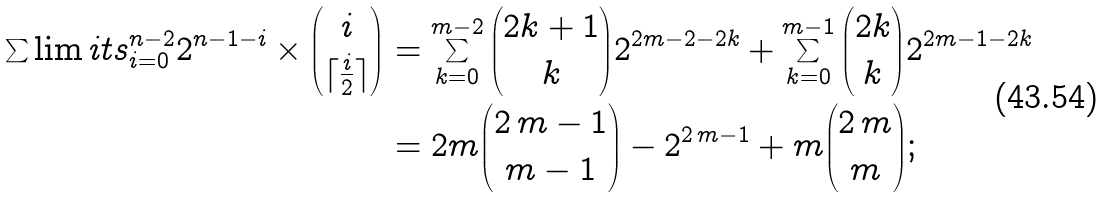Convert formula to latex. <formula><loc_0><loc_0><loc_500><loc_500>\sum \lim i t s _ { i = 0 } ^ { n - 2 } 2 ^ { n - 1 - i } \times { i \choose \lceil \frac { i } { 2 } \rceil } & = \sum _ { k = 0 } ^ { m - 2 } { 2 k + 1 \choose k } 2 ^ { 2 m - 2 - 2 k } + \sum _ { k = 0 } ^ { m - 1 } { 2 k \choose k } 2 ^ { 2 m - 1 - 2 k } \\ & = 2 m { 2 \, m - 1 \choose m - 1 } - { 2 } ^ { 2 \, m - 1 } + m { 2 \, m \choose m } ;</formula> 